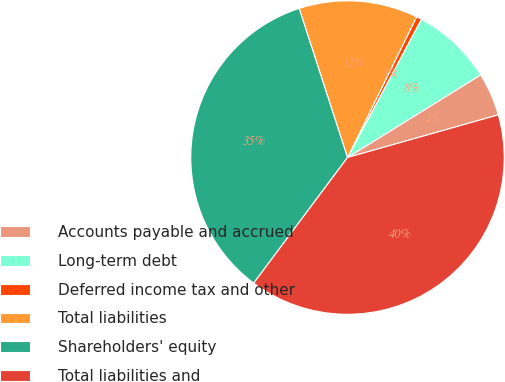Convert chart. <chart><loc_0><loc_0><loc_500><loc_500><pie_chart><fcel>Accounts payable and accrued<fcel>Long-term debt<fcel>Deferred income tax and other<fcel>Total liabilities<fcel>Shareholders' equity<fcel>Total liabilities and<nl><fcel>4.45%<fcel>8.35%<fcel>0.54%<fcel>12.26%<fcel>34.8%<fcel>39.6%<nl></chart> 